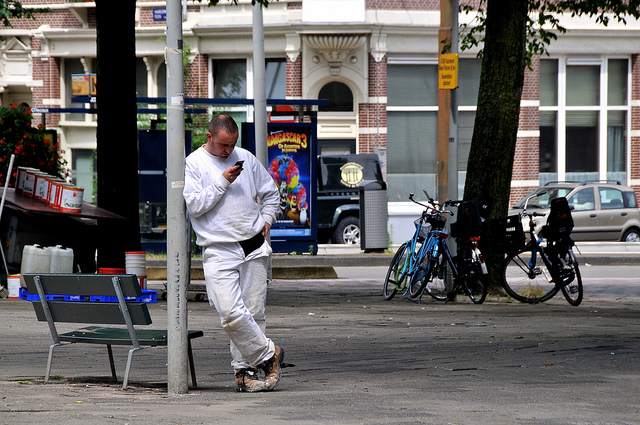Please identify all text content in this image. C 